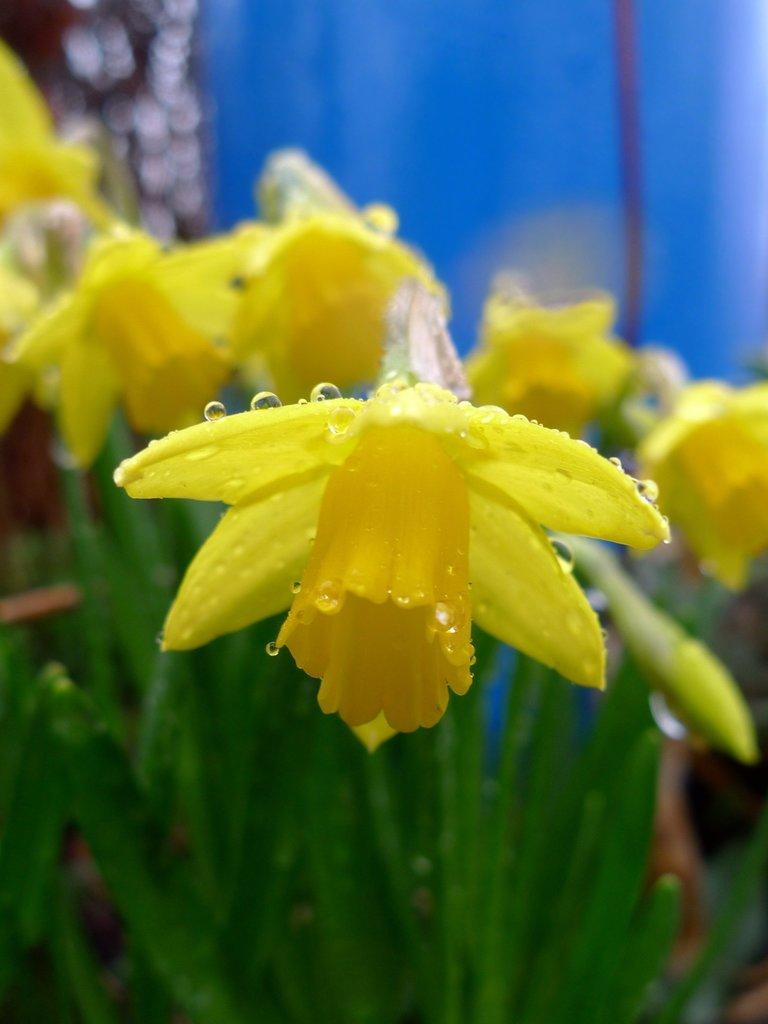What type of plants can be seen in the image? There are flowers in the image. What color are the flowers? The flowers are yellow. What can be observed on the surface of the flowers? There are water droplets on the flowers. What else is visible at the bottom of the image? There are leaves present at the bottom of the image. What color is the background of the image? The background of the image is blue. What type of secretary can be seen working in the image? There is no secretary present in the image; it features flowers with water droplets and a blue background. What type of railway is visible in the image? There is no railway present in the image; it features flowers with water droplets and a blue background. 